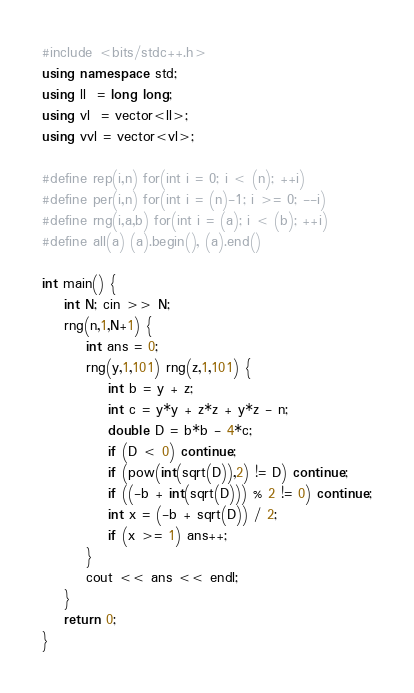<code> <loc_0><loc_0><loc_500><loc_500><_C++_>#include <bits/stdc++.h>
using namespace std;
using ll  = long long;
using vl  = vector<ll>;
using vvl = vector<vl>;

#define rep(i,n) for(int i = 0; i < (n); ++i)
#define per(i,n) for(int i = (n)-1; i >= 0; --i)
#define rng(i,a,b) for(int i = (a); i < (b); ++i)
#define all(a) (a).begin(), (a).end()

int main() {
    int N; cin >> N;
    rng(n,1,N+1) {
        int ans = 0;
        rng(y,1,101) rng(z,1,101) {
            int b = y + z;
            int c = y*y + z*z + y*z - n;
            double D = b*b - 4*c;
            if (D < 0) continue;
            if (pow(int(sqrt(D)),2) != D) continue;
            if ((-b + int(sqrt(D))) % 2 != 0) continue;
            int x = (-b + sqrt(D)) / 2;
            if (x >= 1) ans++;
        }
        cout << ans << endl;
    }
    return 0;
}
</code> 